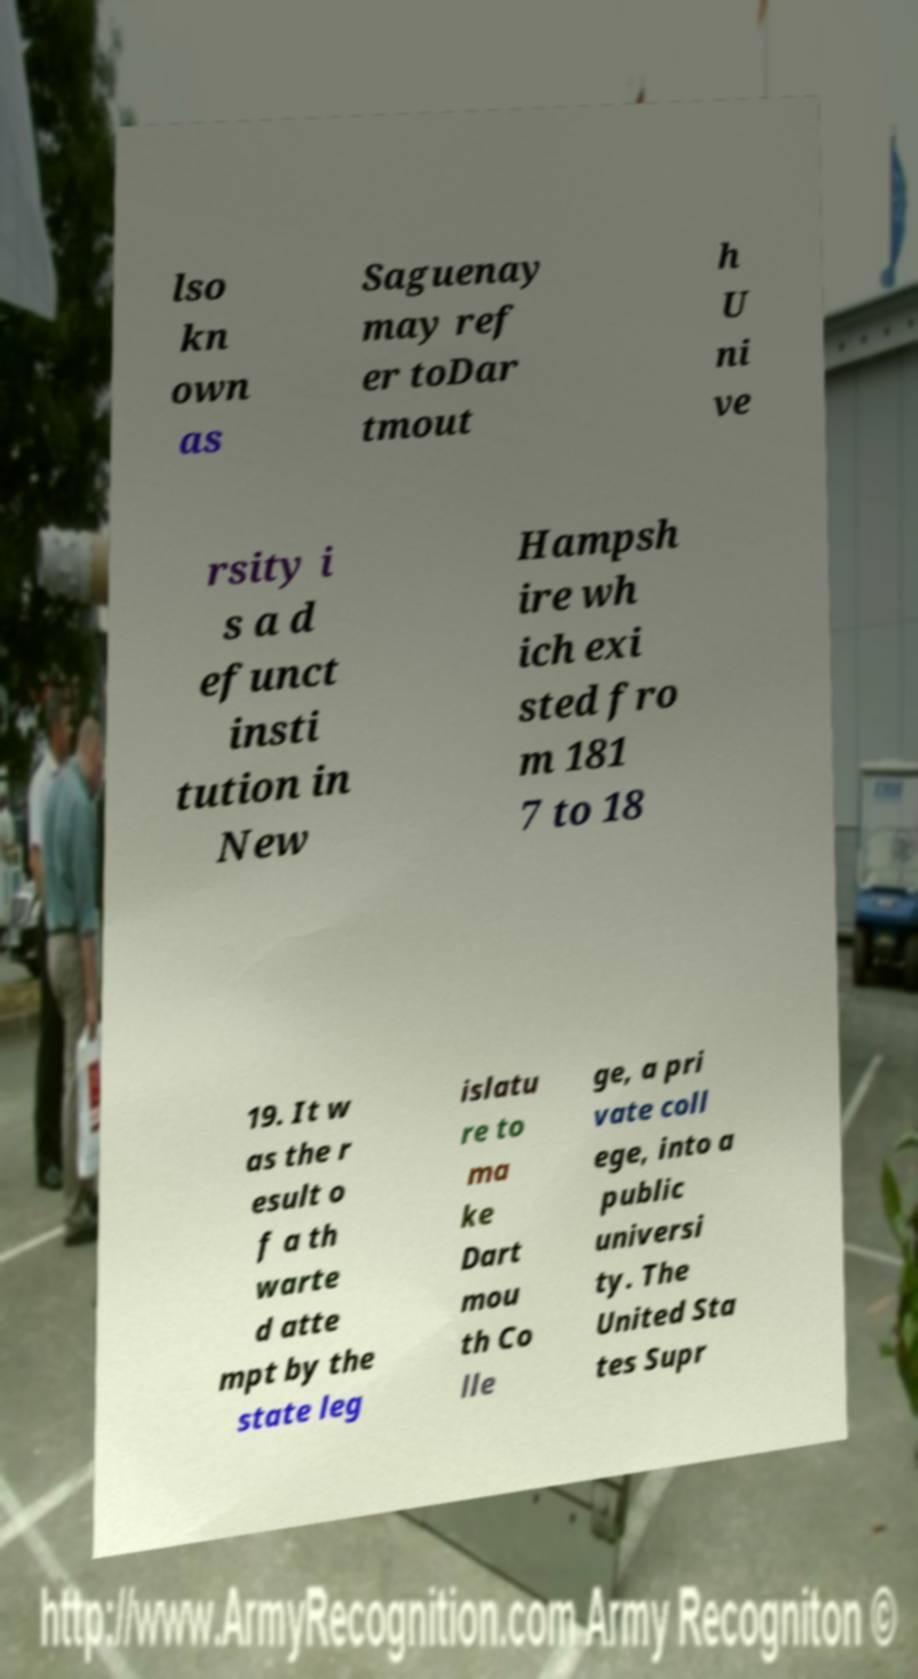There's text embedded in this image that I need extracted. Can you transcribe it verbatim? lso kn own as Saguenay may ref er toDar tmout h U ni ve rsity i s a d efunct insti tution in New Hampsh ire wh ich exi sted fro m 181 7 to 18 19. It w as the r esult o f a th warte d atte mpt by the state leg islatu re to ma ke Dart mou th Co lle ge, a pri vate coll ege, into a public universi ty. The United Sta tes Supr 